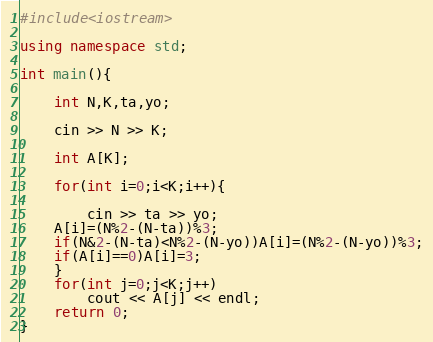Convert code to text. <code><loc_0><loc_0><loc_500><loc_500><_C++_>#include<iostream>

using namespace std;

int main(){

    int N,K,ta,yo;

    cin >> N >> K;

    int A[K];

    for(int i=0;i<K;i++){

        cin >> ta >> yo;
    A[i]=(N%2-(N-ta))%3;
    if(N&2-(N-ta)<N%2-(N-yo))A[i]=(N%2-(N-yo))%3;
    if(A[i]==0)A[i]=3;
    }
    for(int j=0;j<K;j++)
        cout << A[j] << endl;
    return 0;
}</code> 